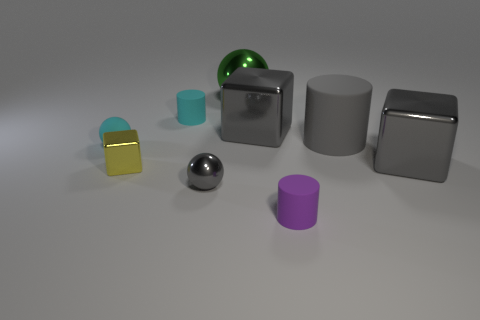Add 1 small gray blocks. How many objects exist? 10 Subtract all blocks. How many objects are left? 6 Add 1 metallic objects. How many metallic objects exist? 6 Subtract 0 cyan blocks. How many objects are left? 9 Subtract all cubes. Subtract all big green rubber things. How many objects are left? 6 Add 7 small yellow objects. How many small yellow objects are left? 8 